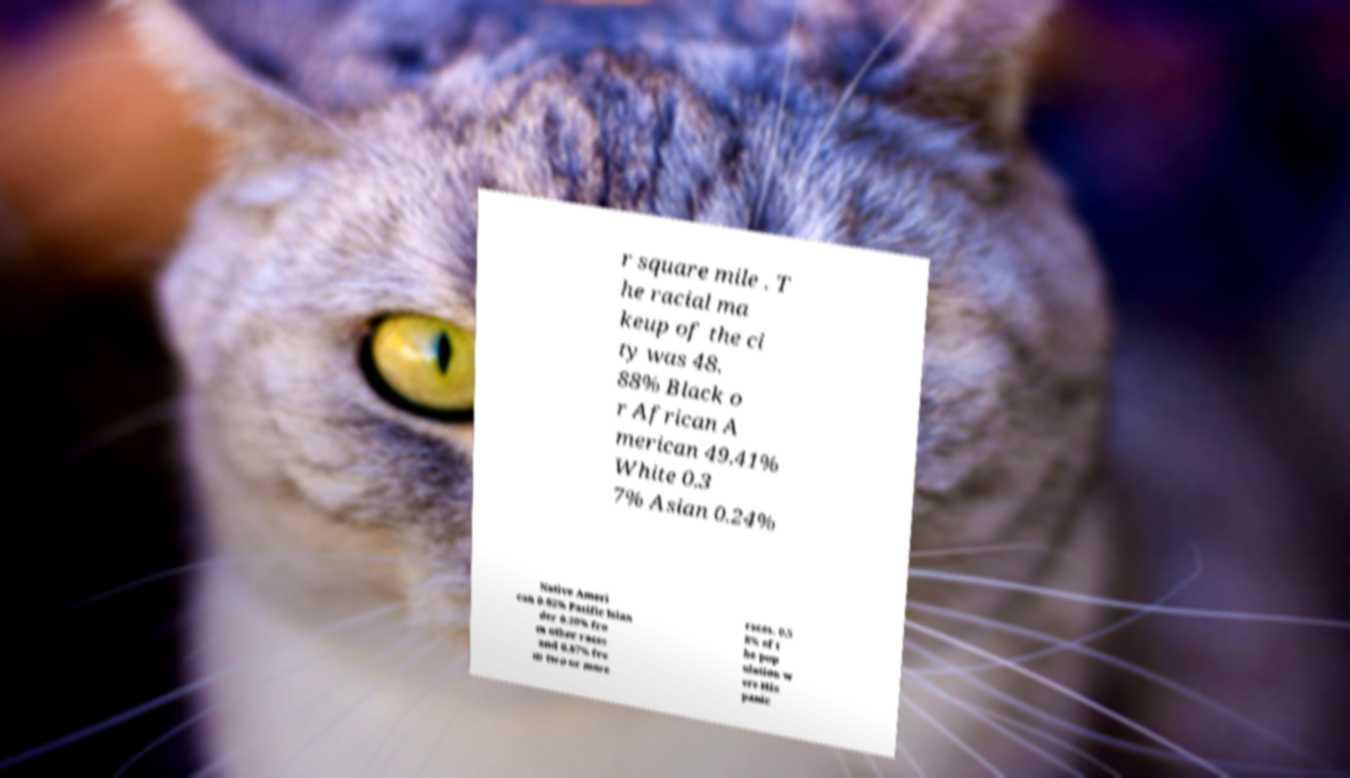Could you extract and type out the text from this image? r square mile . T he racial ma keup of the ci ty was 48. 88% Black o r African A merican 49.41% White 0.3 7% Asian 0.24% Native Ameri can 0.02% Pacific Islan der 0.20% fro m other races and 0.87% fro m two or more races. 0.5 8% of t he pop ulation w ere His panic 